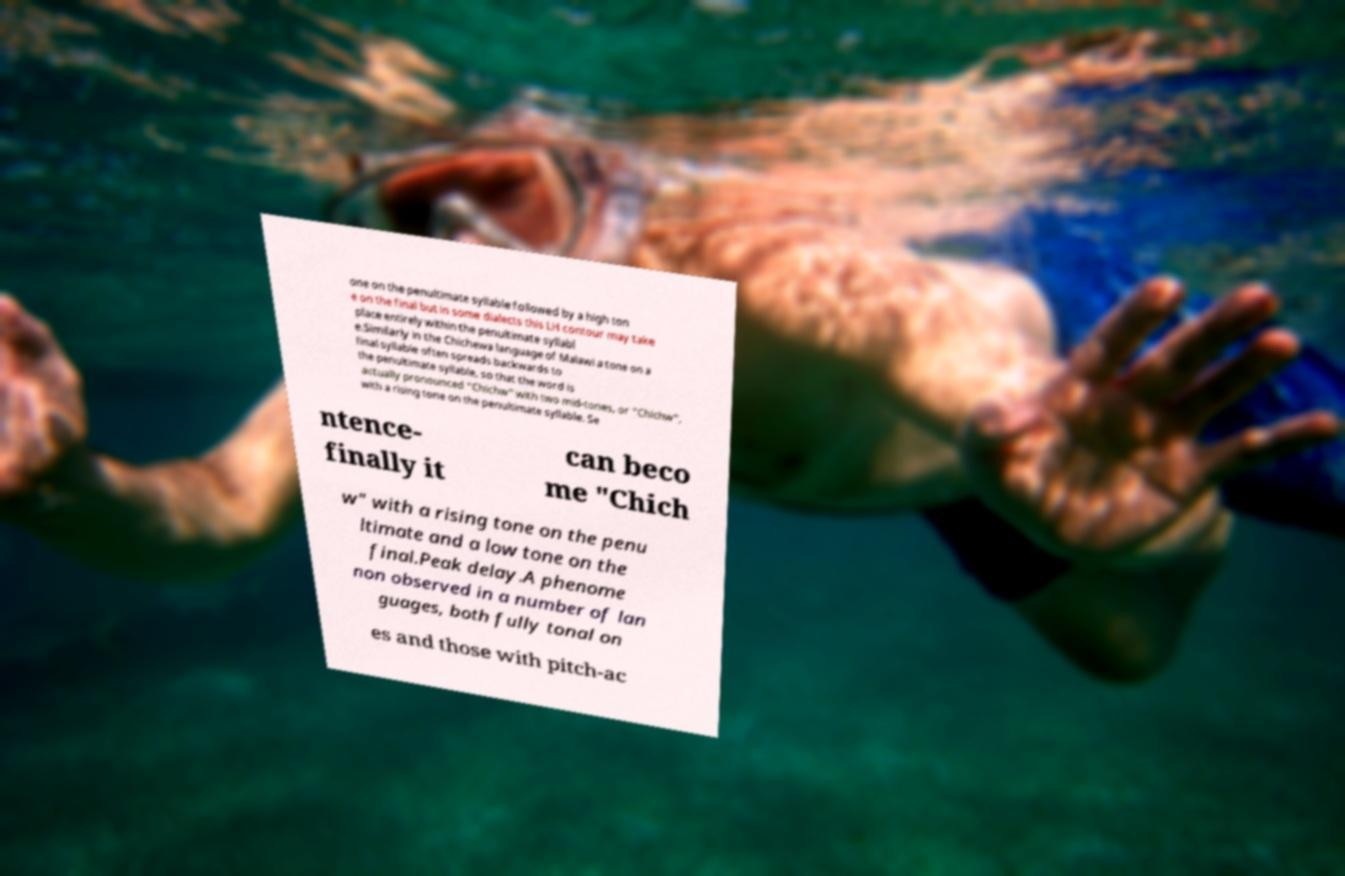There's text embedded in this image that I need extracted. Can you transcribe it verbatim? one on the penultimate syllable followed by a high ton e on the final but in some dialects this LH contour may take place entirely within the penultimate syllabl e.Similarly in the Chichewa language of Malawi a tone on a final syllable often spreads backwards to the penultimate syllable, so that the word is actually pronounced "Chichw" with two mid-tones, or "Chichw", with a rising tone on the penultimate syllable. Se ntence- finally it can beco me "Chich w" with a rising tone on the penu ltimate and a low tone on the final.Peak delay.A phenome non observed in a number of lan guages, both fully tonal on es and those with pitch-ac 